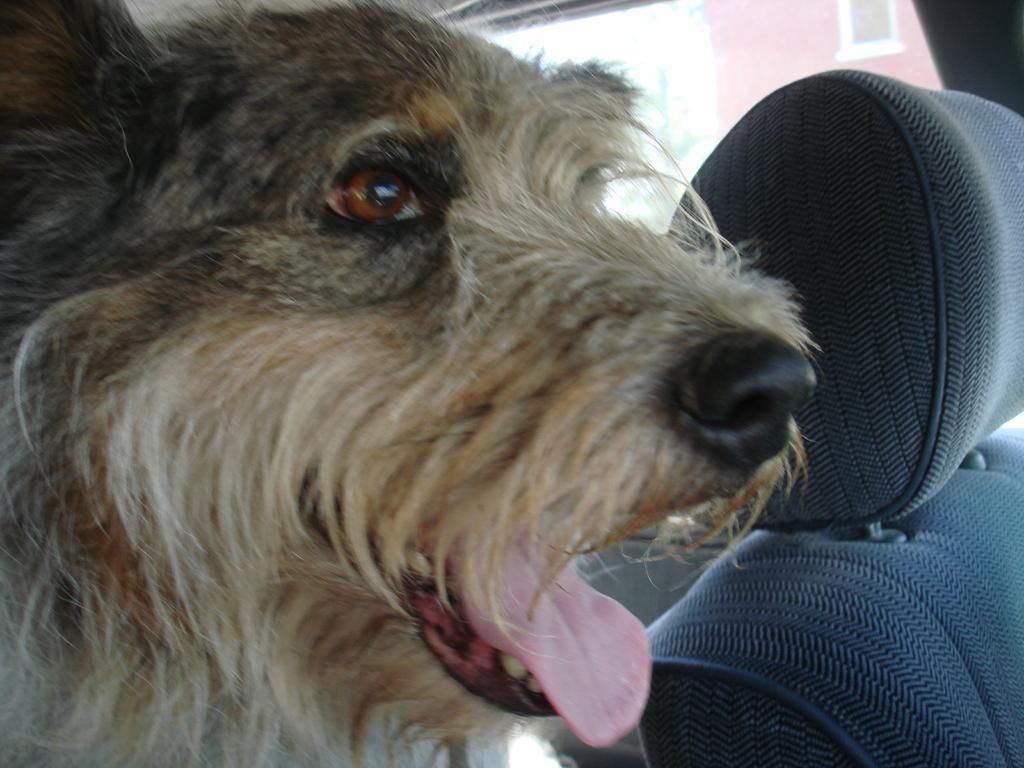How would you summarize this image in a sentence or two? In this picture we can see a dog inside the vehicle and we can see a seat. 